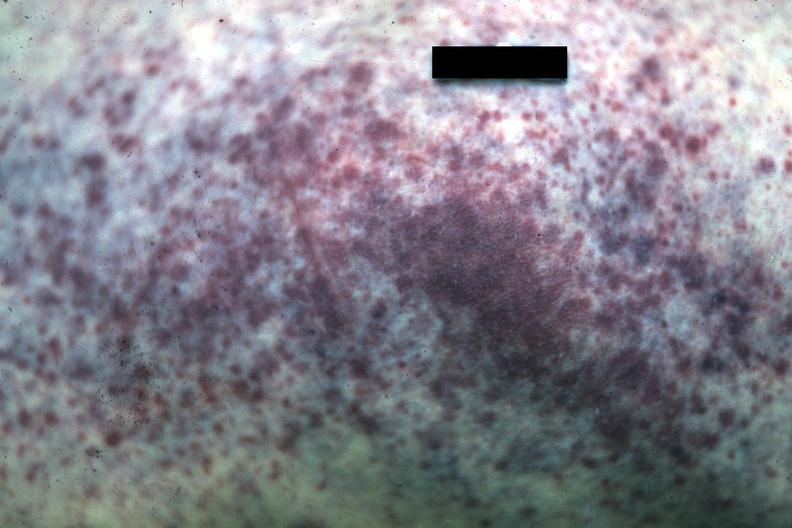where is this?
Answer the question using a single word or phrase. Skin 